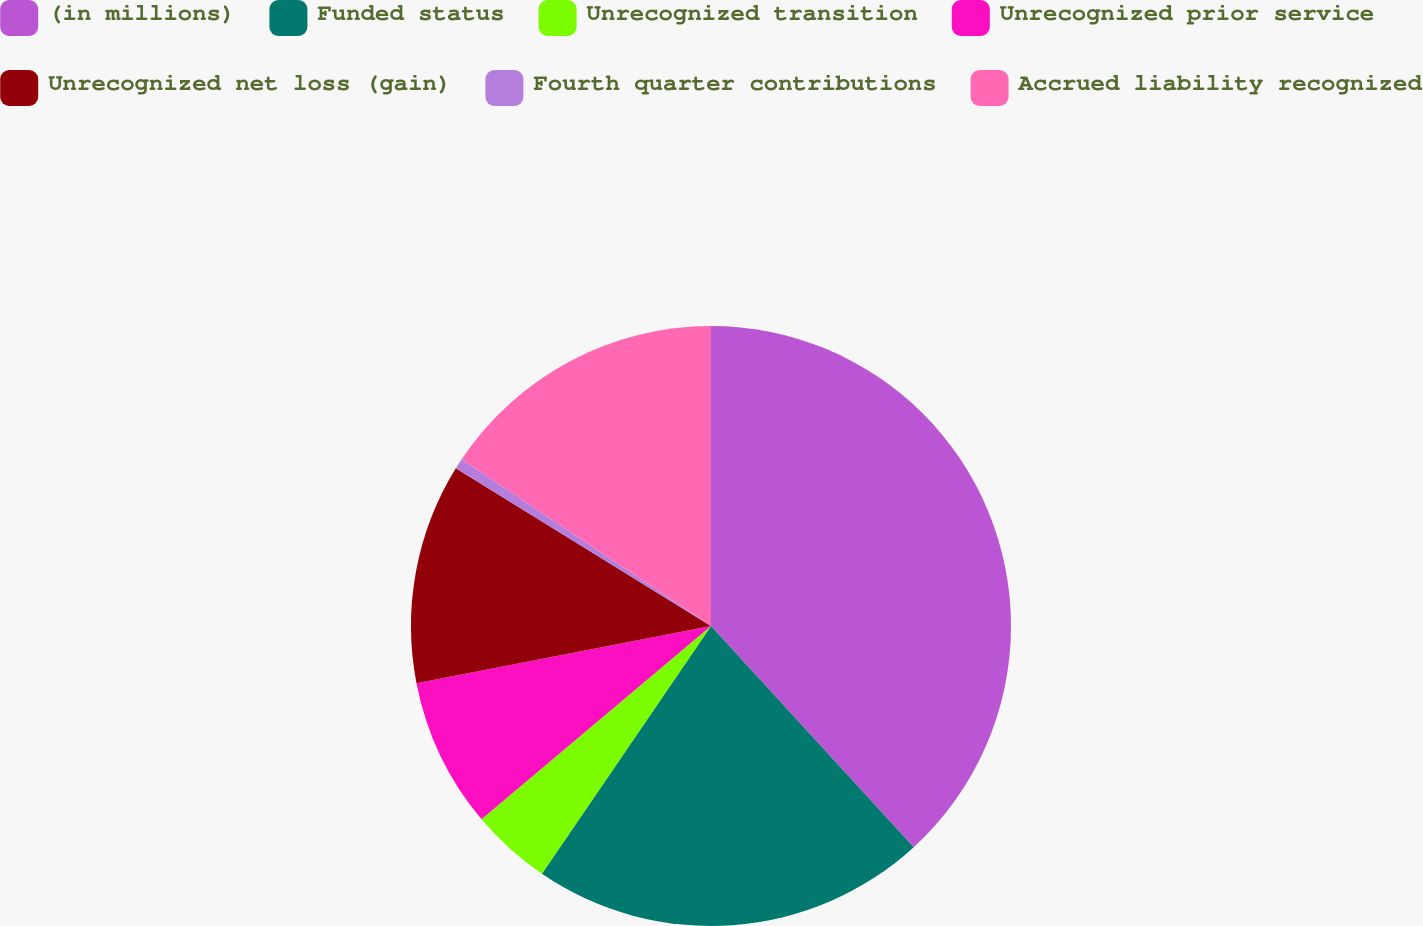Convert chart. <chart><loc_0><loc_0><loc_500><loc_500><pie_chart><fcel>(in millions)<fcel>Funded status<fcel>Unrecognized transition<fcel>Unrecognized prior service<fcel>Unrecognized net loss (gain)<fcel>Fourth quarter contributions<fcel>Accrued liability recognized<nl><fcel>38.19%<fcel>21.34%<fcel>4.33%<fcel>8.09%<fcel>11.86%<fcel>0.57%<fcel>15.62%<nl></chart> 